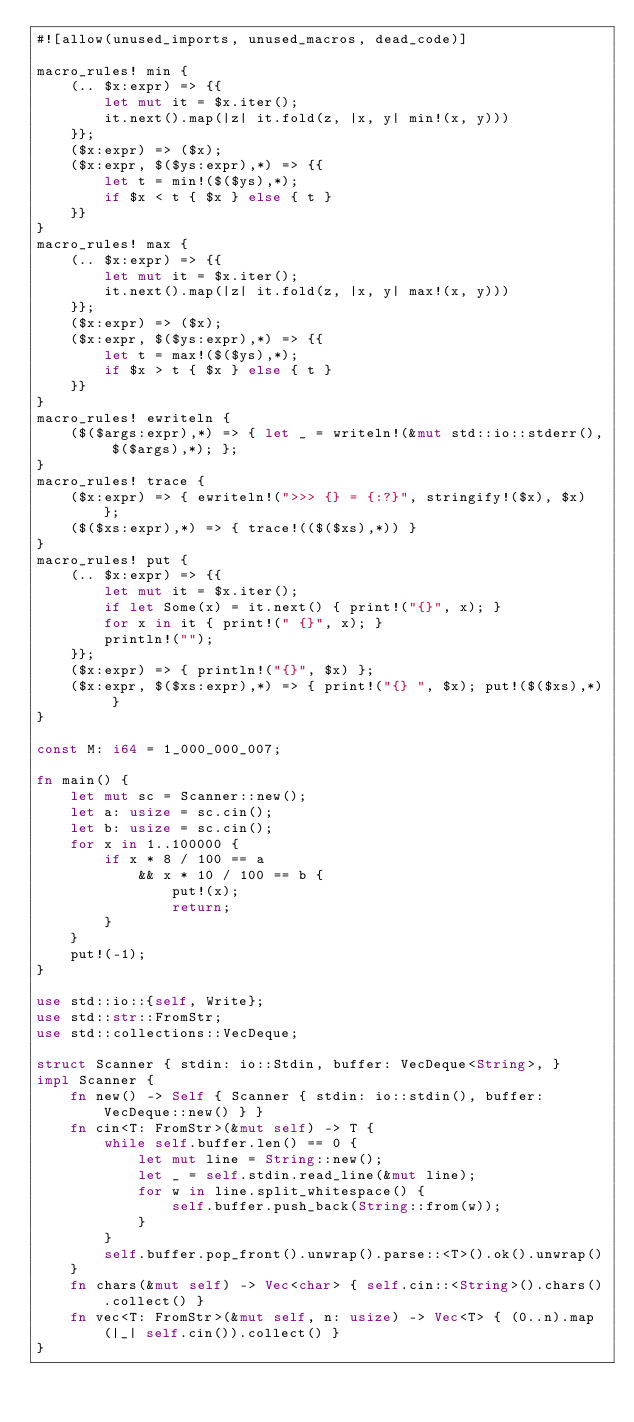<code> <loc_0><loc_0><loc_500><loc_500><_Rust_>#![allow(unused_imports, unused_macros, dead_code)]

macro_rules! min {
    (.. $x:expr) => {{
        let mut it = $x.iter();
        it.next().map(|z| it.fold(z, |x, y| min!(x, y)))
    }};
    ($x:expr) => ($x);
    ($x:expr, $($ys:expr),*) => {{
        let t = min!($($ys),*);
        if $x < t { $x } else { t }
    }}
}
macro_rules! max {
    (.. $x:expr) => {{
        let mut it = $x.iter();
        it.next().map(|z| it.fold(z, |x, y| max!(x, y)))
    }};
    ($x:expr) => ($x);
    ($x:expr, $($ys:expr),*) => {{
        let t = max!($($ys),*);
        if $x > t { $x } else { t }
    }}
}
macro_rules! ewriteln {
    ($($args:expr),*) => { let _ = writeln!(&mut std::io::stderr(), $($args),*); };
}
macro_rules! trace {
    ($x:expr) => { ewriteln!(">>> {} = {:?}", stringify!($x), $x) };
    ($($xs:expr),*) => { trace!(($($xs),*)) }
}
macro_rules! put {
    (.. $x:expr) => {{
        let mut it = $x.iter();
        if let Some(x) = it.next() { print!("{}", x); }
        for x in it { print!(" {}", x); }
        println!("");
    }};
    ($x:expr) => { println!("{}", $x) };
    ($x:expr, $($xs:expr),*) => { print!("{} ", $x); put!($($xs),*) }
}

const M: i64 = 1_000_000_007;

fn main() {
    let mut sc = Scanner::new();
    let a: usize = sc.cin();
    let b: usize = sc.cin();
    for x in 1..100000 {
        if x * 8 / 100 == a
            && x * 10 / 100 == b {
                put!(x);
                return;
        }
    }
    put!(-1);
}

use std::io::{self, Write};
use std::str::FromStr;
use std::collections::VecDeque;

struct Scanner { stdin: io::Stdin, buffer: VecDeque<String>, }
impl Scanner {
    fn new() -> Self { Scanner { stdin: io::stdin(), buffer: VecDeque::new() } }
    fn cin<T: FromStr>(&mut self) -> T {
        while self.buffer.len() == 0 {
            let mut line = String::new();
            let _ = self.stdin.read_line(&mut line);
            for w in line.split_whitespace() {
                self.buffer.push_back(String::from(w));
            }
        }
        self.buffer.pop_front().unwrap().parse::<T>().ok().unwrap()
    }
    fn chars(&mut self) -> Vec<char> { self.cin::<String>().chars().collect() }
    fn vec<T: FromStr>(&mut self, n: usize) -> Vec<T> { (0..n).map(|_| self.cin()).collect() }
}
</code> 